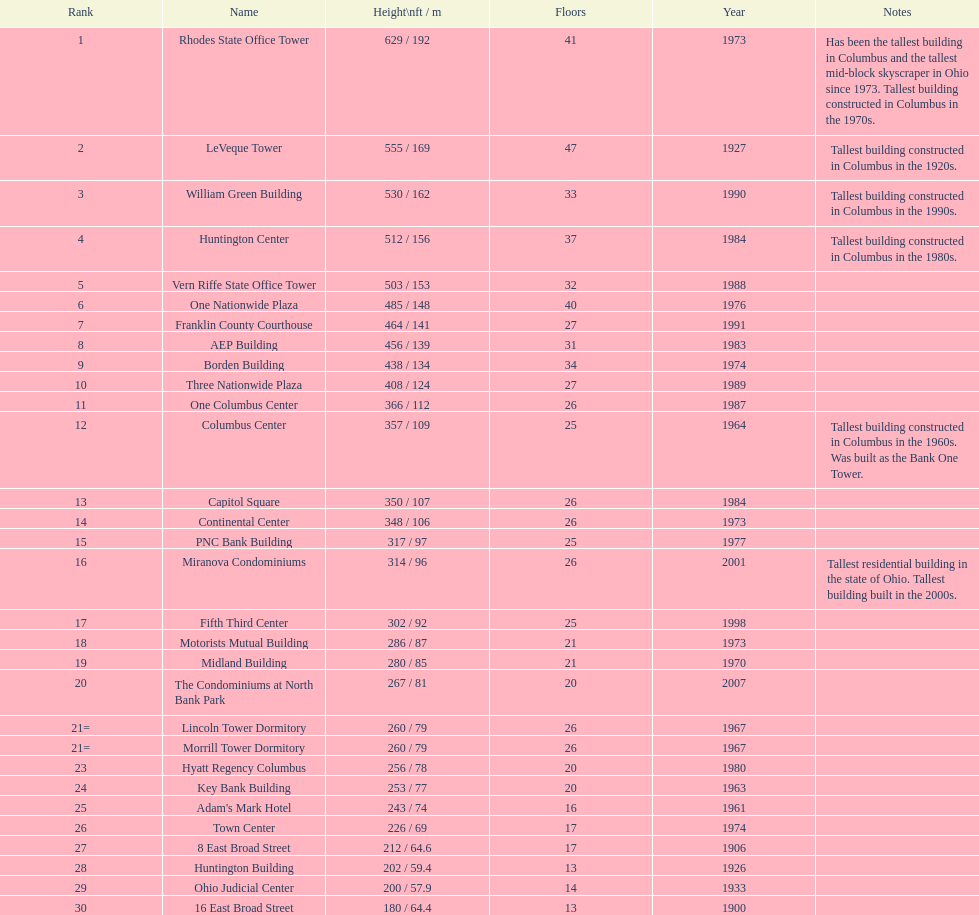How many floors does the capitol square have? 26. 